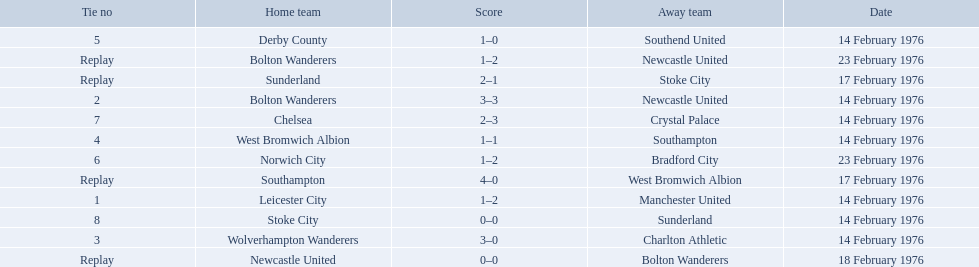What teams are featured in the game at the top of the table? Leicester City, Manchester United. Which of these two is the home team? Leicester City. 